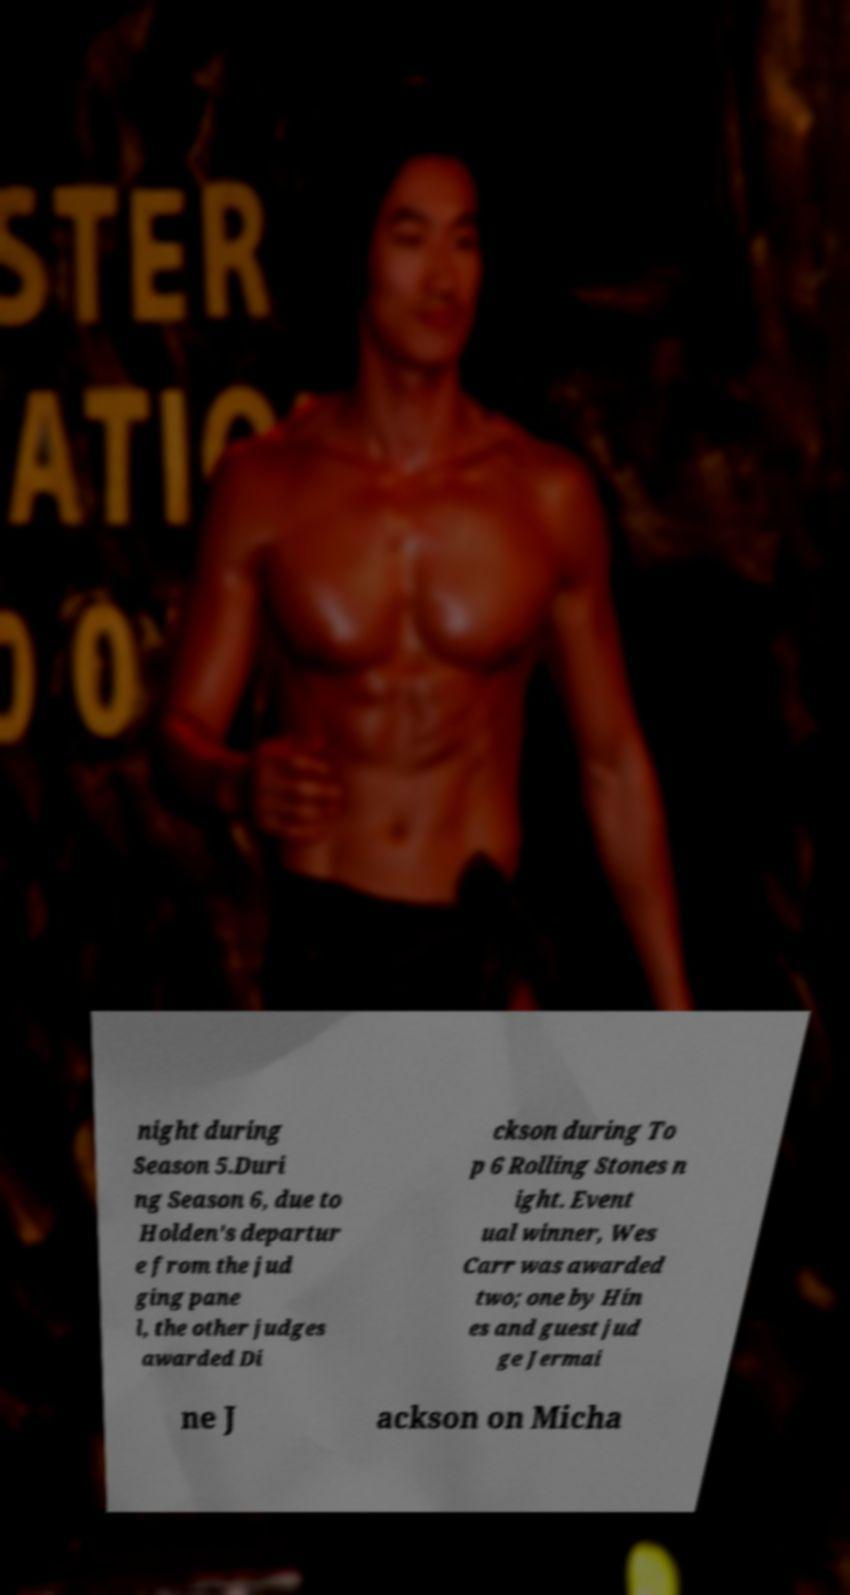Can you read and provide the text displayed in the image?This photo seems to have some interesting text. Can you extract and type it out for me? night during Season 5.Duri ng Season 6, due to Holden's departur e from the jud ging pane l, the other judges awarded Di ckson during To p 6 Rolling Stones n ight. Event ual winner, Wes Carr was awarded two; one by Hin es and guest jud ge Jermai ne J ackson on Micha 